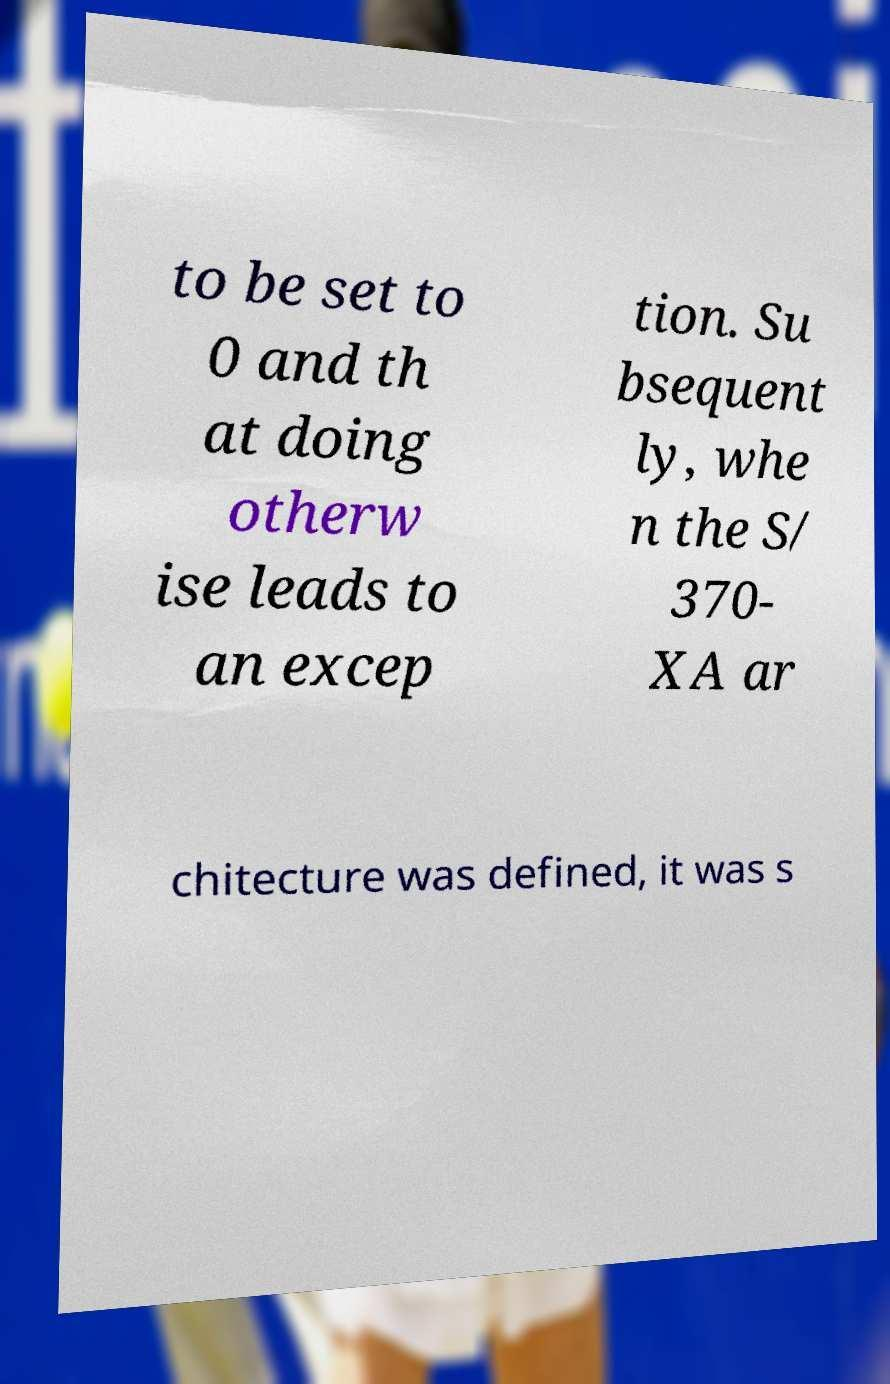Can you read and provide the text displayed in the image?This photo seems to have some interesting text. Can you extract and type it out for me? to be set to 0 and th at doing otherw ise leads to an excep tion. Su bsequent ly, whe n the S/ 370- XA ar chitecture was defined, it was s 